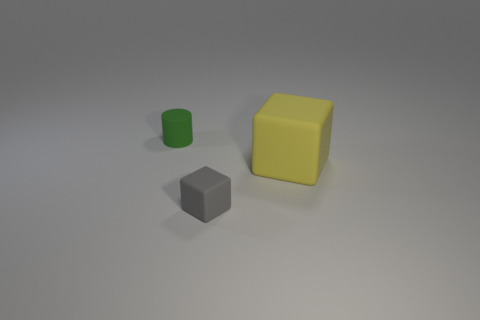What color is the tiny cylinder that is made of the same material as the big yellow block?
Your answer should be very brief. Green. Is the shape of the tiny thing to the right of the green cylinder the same as the small rubber thing that is behind the large yellow rubber object?
Offer a terse response. No. How many rubber things are either small green things or small cubes?
Keep it short and to the point. 2. Is there anything else that is the same shape as the small green matte thing?
Make the answer very short. No. There is a tiny thing that is on the left side of the small gray matte thing; what material is it?
Offer a very short reply. Rubber. Is the small object that is right of the small green rubber object made of the same material as the green object?
Give a very brief answer. Yes. How many things are green things or rubber objects that are in front of the yellow rubber block?
Your response must be concise. 2. There is a gray rubber thing that is the same shape as the yellow matte thing; what size is it?
Your answer should be very brief. Small. Is there anything else that is the same size as the gray thing?
Your response must be concise. Yes. Are there any small rubber blocks right of the big block?
Your answer should be very brief. No. 